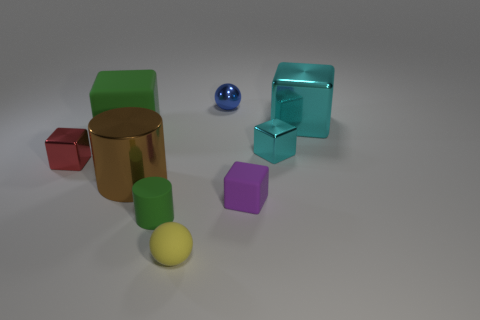Is the shape of the tiny metallic thing to the right of the small blue ball the same as the metallic object that is in front of the tiny red block?
Your response must be concise. No. Is the number of tiny red shiny objects to the right of the purple block less than the number of green objects behind the blue thing?
Your response must be concise. No. What number of other things are the same shape as the large green matte thing?
Offer a very short reply. 4. There is a red object that is made of the same material as the blue object; what is its shape?
Offer a terse response. Cube. What color is the object that is on the left side of the rubber cylinder and in front of the red shiny object?
Provide a short and direct response. Brown. Are the green object left of the brown cylinder and the yellow ball made of the same material?
Offer a very short reply. Yes. Is the number of metal things that are in front of the yellow thing less than the number of green objects?
Keep it short and to the point. Yes. Are there any small green things that have the same material as the purple cube?
Your answer should be compact. Yes. Do the red object and the green matte object behind the purple matte block have the same size?
Provide a short and direct response. No. Are there any things that have the same color as the big metal cube?
Provide a succinct answer. Yes. 